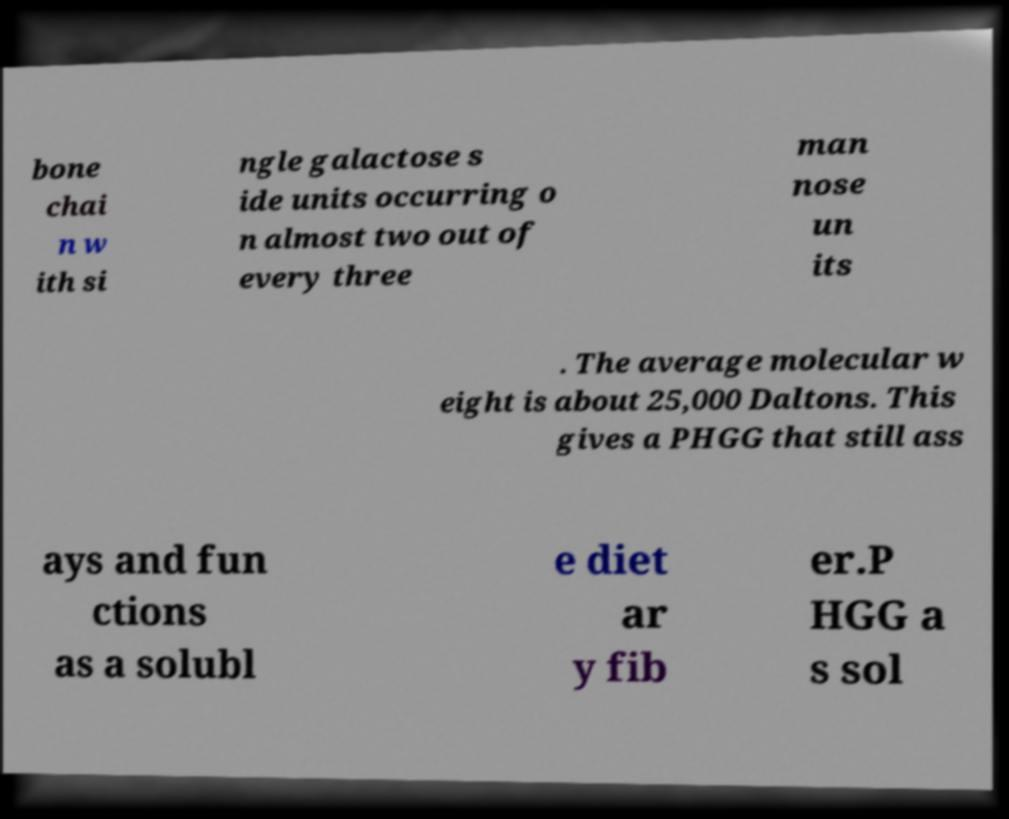I need the written content from this picture converted into text. Can you do that? bone chai n w ith si ngle galactose s ide units occurring o n almost two out of every three man nose un its . The average molecular w eight is about 25,000 Daltons. This gives a PHGG that still ass ays and fun ctions as a solubl e diet ar y fib er.P HGG a s sol 